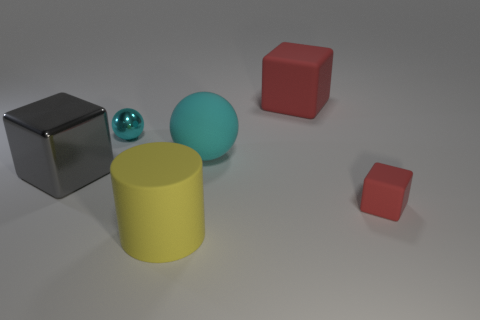Subtract all large red blocks. How many blocks are left? 2 Add 4 big green balls. How many objects exist? 10 Subtract all gray blocks. How many blocks are left? 2 Add 3 cyan things. How many cyan things are left? 5 Add 3 gray rubber cylinders. How many gray rubber cylinders exist? 3 Subtract 0 purple balls. How many objects are left? 6 Subtract all spheres. How many objects are left? 4 Subtract 1 cubes. How many cubes are left? 2 Subtract all green blocks. Subtract all purple cylinders. How many blocks are left? 3 Subtract all cyan blocks. How many purple balls are left? 0 